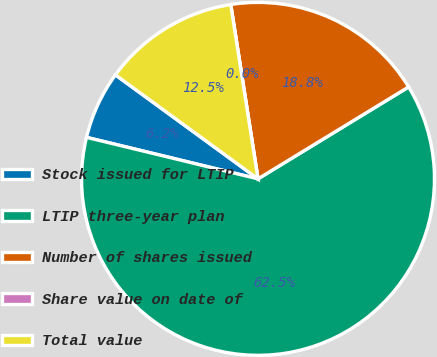Convert chart. <chart><loc_0><loc_0><loc_500><loc_500><pie_chart><fcel>Stock issued for LTIP<fcel>LTIP three-year plan<fcel>Number of shares issued<fcel>Share value on date of<fcel>Total value<nl><fcel>6.25%<fcel>62.5%<fcel>18.75%<fcel>0.0%<fcel>12.5%<nl></chart> 